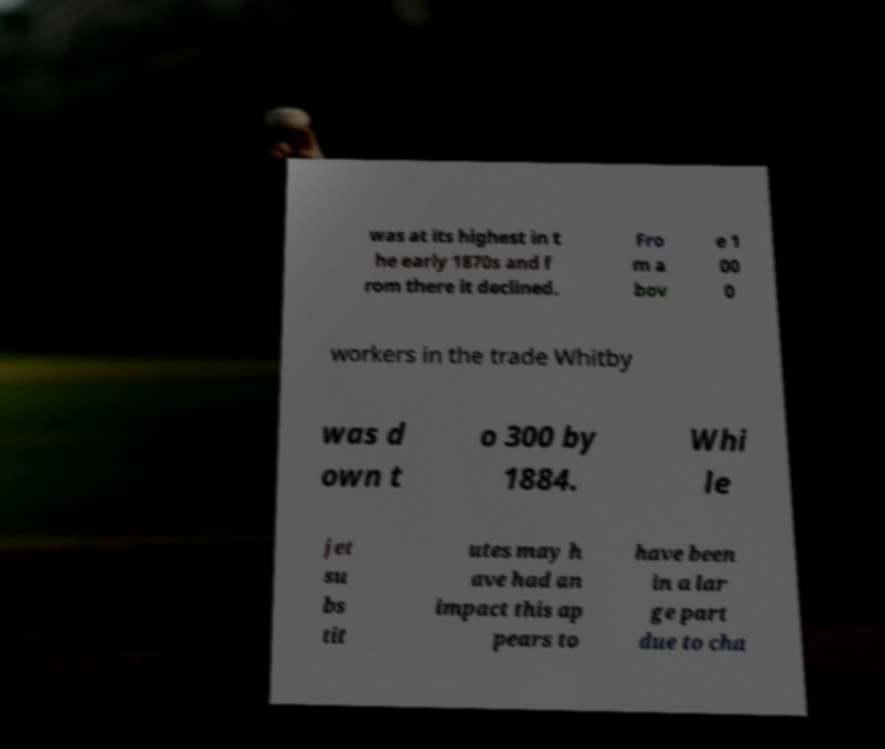For documentation purposes, I need the text within this image transcribed. Could you provide that? was at its highest in t he early 1870s and f rom there it declined. Fro m a bov e 1 00 0 workers in the trade Whitby was d own t o 300 by 1884. Whi le jet su bs tit utes may h ave had an impact this ap pears to have been in a lar ge part due to cha 